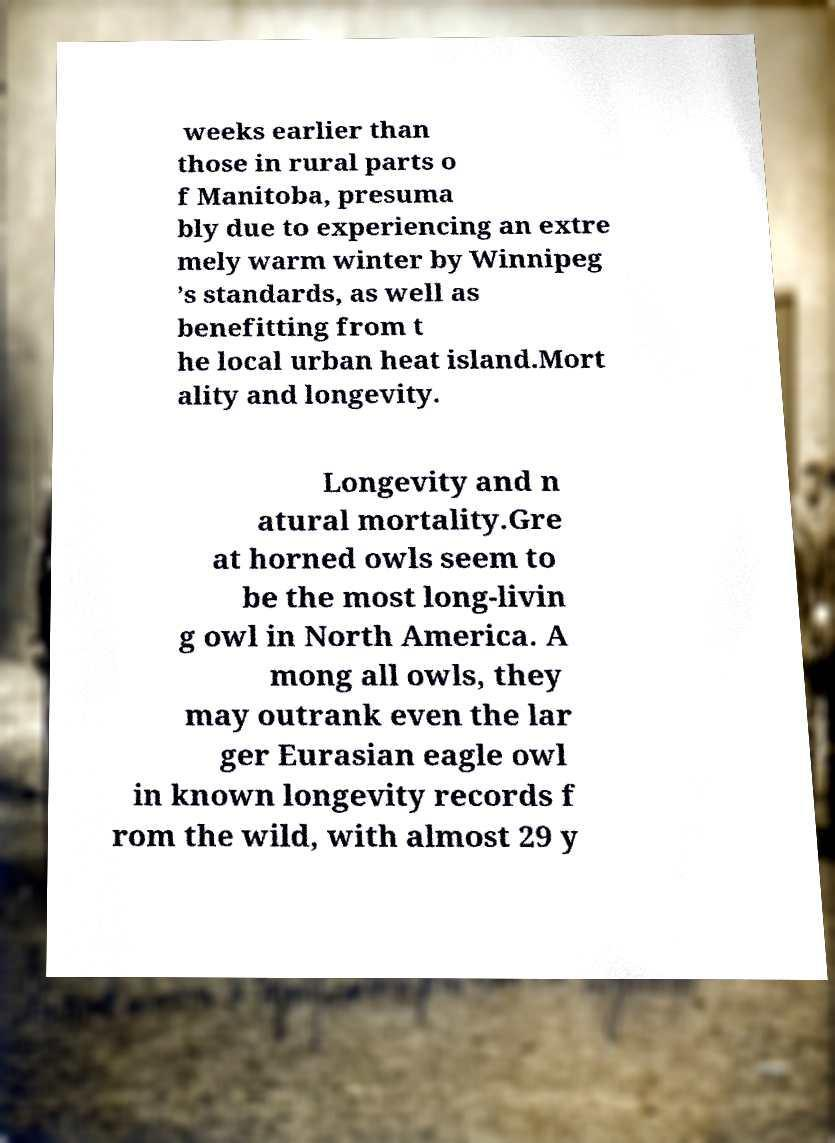What messages or text are displayed in this image? I need them in a readable, typed format. weeks earlier than those in rural parts o f Manitoba, presuma bly due to experiencing an extre mely warm winter by Winnipeg ’s standards, as well as benefitting from t he local urban heat island.Mort ality and longevity. Longevity and n atural mortality.Gre at horned owls seem to be the most long-livin g owl in North America. A mong all owls, they may outrank even the lar ger Eurasian eagle owl in known longevity records f rom the wild, with almost 29 y 